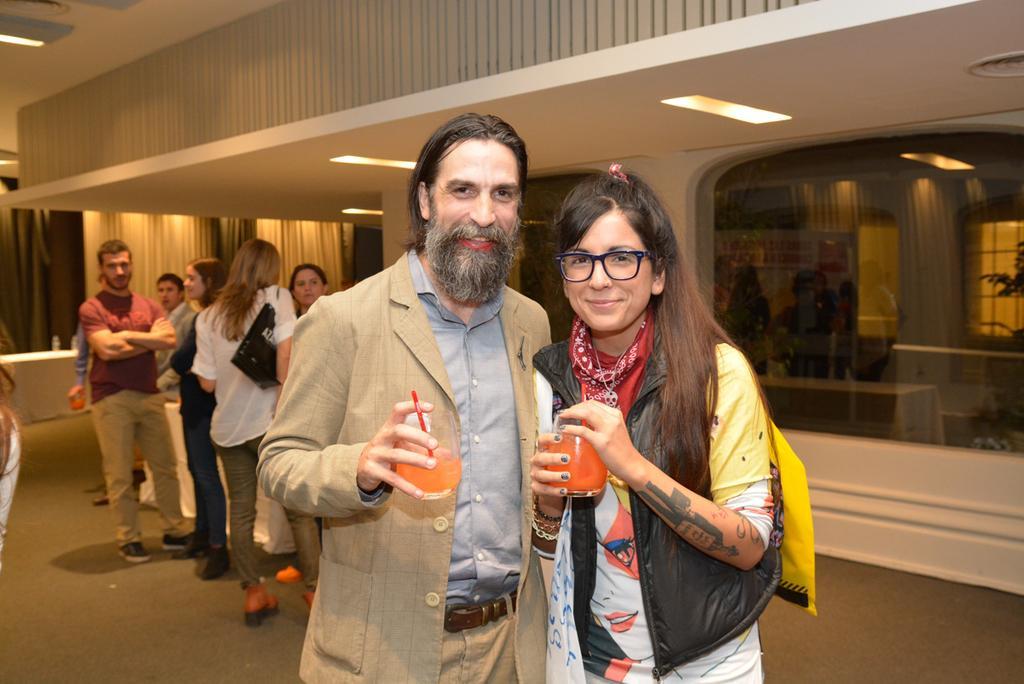Please provide a concise description of this image. In this picture we can observe a couple holding juice glasses in their hands. One of them is a man wearing cream color coat and the other is a woman wearing black color jacket and spectacles. Both of them are smiling. In the background there are some people standing. We can observe cream and black color curtains here. 